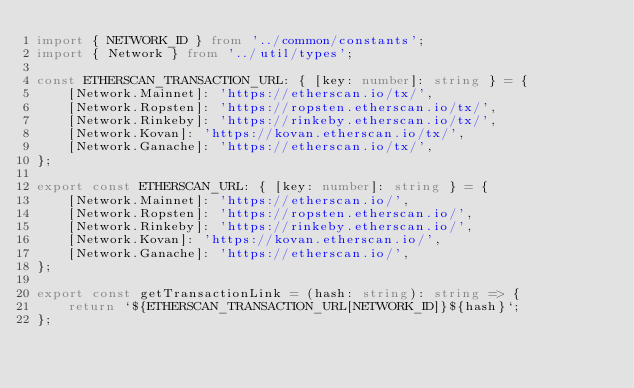Convert code to text. <code><loc_0><loc_0><loc_500><loc_500><_TypeScript_>import { NETWORK_ID } from '../common/constants';
import { Network } from '../util/types';

const ETHERSCAN_TRANSACTION_URL: { [key: number]: string } = {
    [Network.Mainnet]: 'https://etherscan.io/tx/',
    [Network.Ropsten]: 'https://ropsten.etherscan.io/tx/',
    [Network.Rinkeby]: 'https://rinkeby.etherscan.io/tx/',
    [Network.Kovan]: 'https://kovan.etherscan.io/tx/',
    [Network.Ganache]: 'https://etherscan.io/tx/',
};

export const ETHERSCAN_URL: { [key: number]: string } = {
    [Network.Mainnet]: 'https://etherscan.io/',
    [Network.Ropsten]: 'https://ropsten.etherscan.io/',
    [Network.Rinkeby]: 'https://rinkeby.etherscan.io/',
    [Network.Kovan]: 'https://kovan.etherscan.io/',
    [Network.Ganache]: 'https://etherscan.io/',
};

export const getTransactionLink = (hash: string): string => {
    return `${ETHERSCAN_TRANSACTION_URL[NETWORK_ID]}${hash}`;
};
</code> 